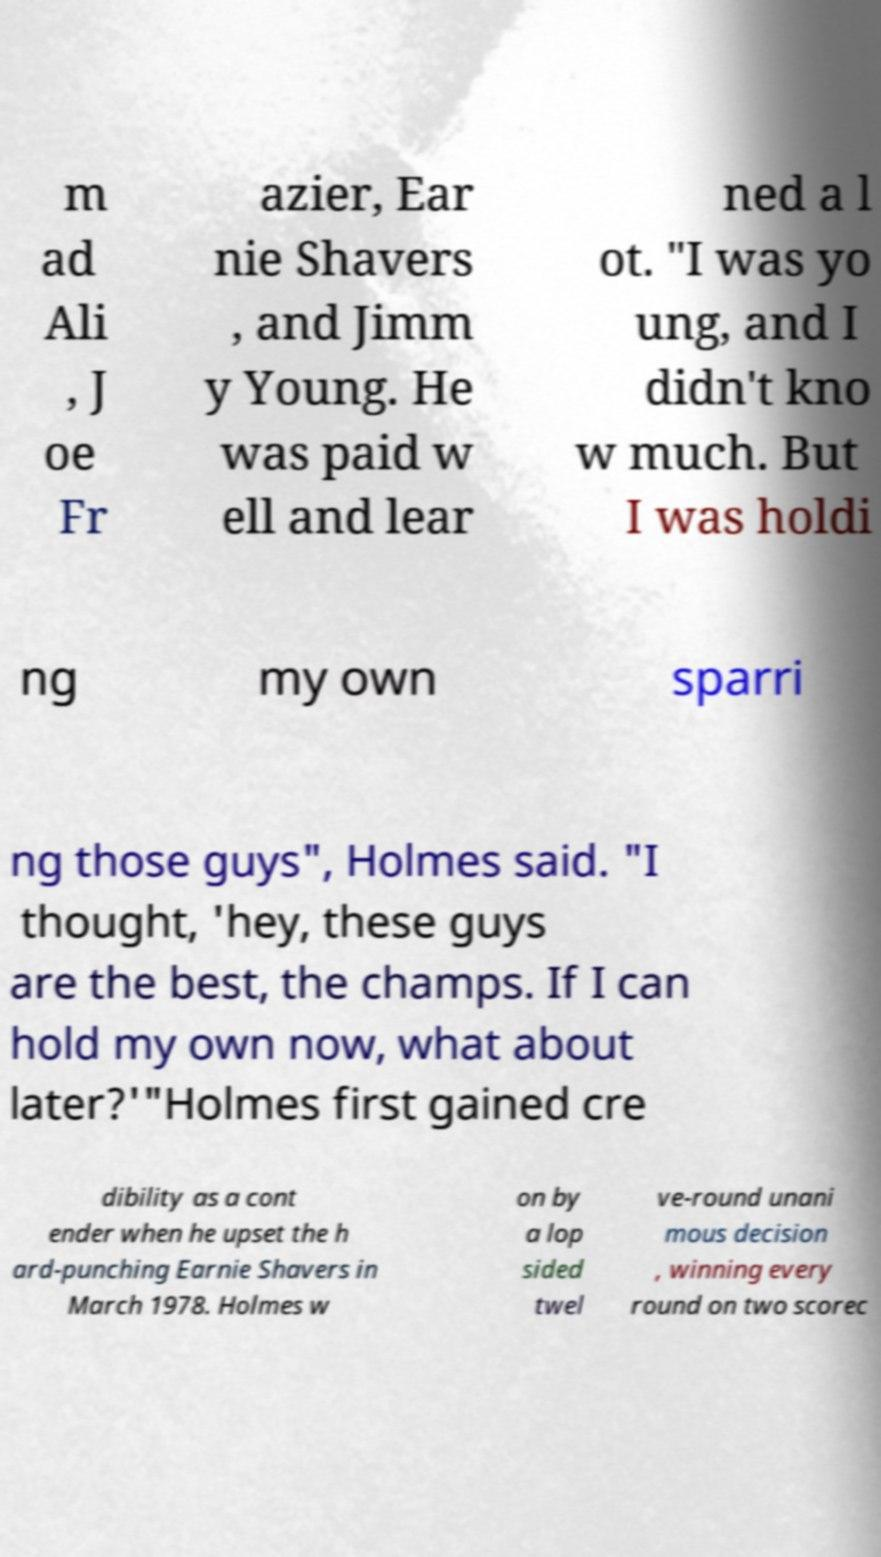Could you assist in decoding the text presented in this image and type it out clearly? m ad Ali , J oe Fr azier, Ear nie Shavers , and Jimm y Young. He was paid w ell and lear ned a l ot. "I was yo ung, and I didn't kno w much. But I was holdi ng my own sparri ng those guys", Holmes said. "I thought, 'hey, these guys are the best, the champs. If I can hold my own now, what about later?'"Holmes first gained cre dibility as a cont ender when he upset the h ard-punching Earnie Shavers in March 1978. Holmes w on by a lop sided twel ve-round unani mous decision , winning every round on two scorec 